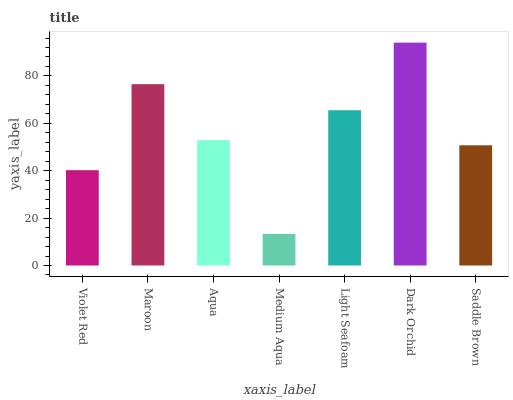Is Maroon the minimum?
Answer yes or no. No. Is Maroon the maximum?
Answer yes or no. No. Is Maroon greater than Violet Red?
Answer yes or no. Yes. Is Violet Red less than Maroon?
Answer yes or no. Yes. Is Violet Red greater than Maroon?
Answer yes or no. No. Is Maroon less than Violet Red?
Answer yes or no. No. Is Aqua the high median?
Answer yes or no. Yes. Is Aqua the low median?
Answer yes or no. Yes. Is Violet Red the high median?
Answer yes or no. No. Is Violet Red the low median?
Answer yes or no. No. 